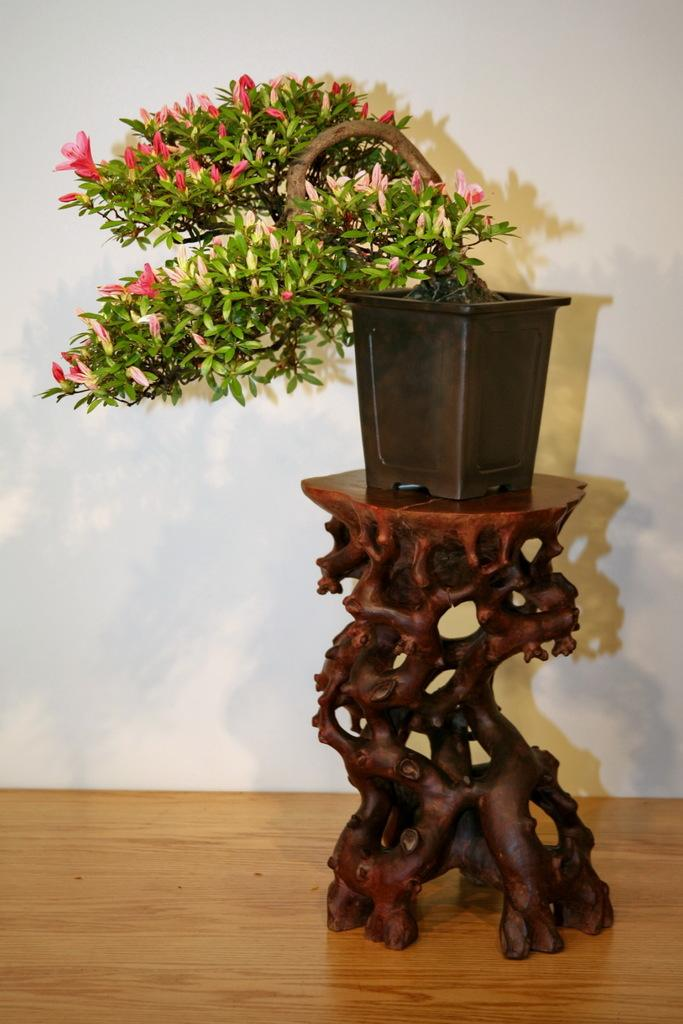What type of plant is in the image? There is a house plant in the image. Where is the house plant located? The house plant is on a table. What type of button can be seen on the country bridge in the image? There is no button, country, or bridge present in the image; it only features a house plant on a table. 